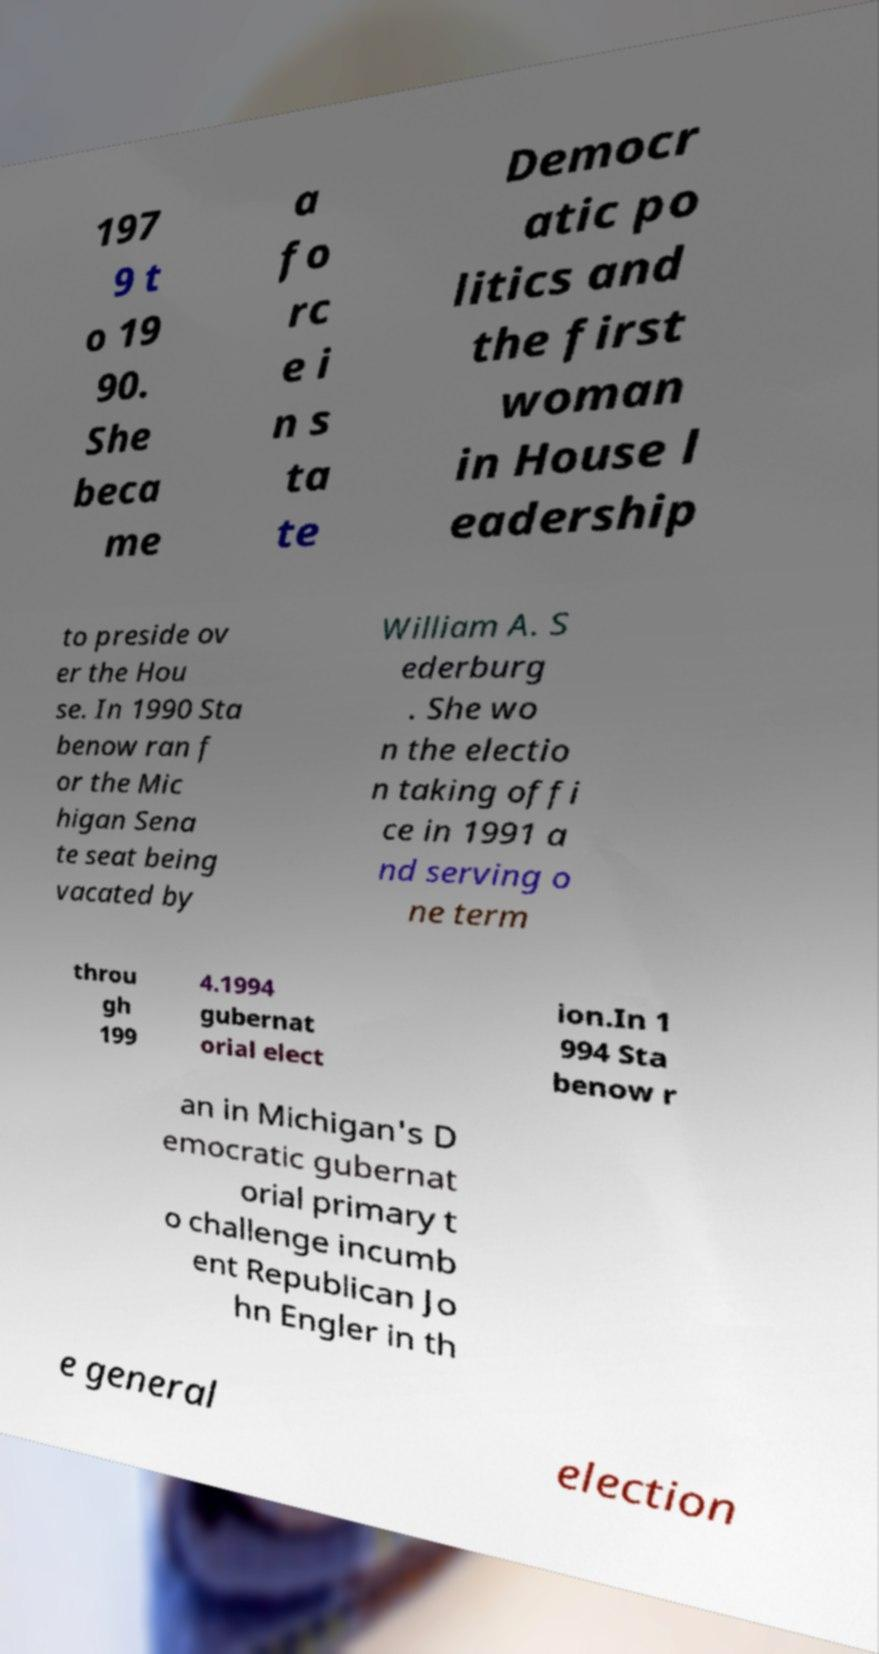I need the written content from this picture converted into text. Can you do that? 197 9 t o 19 90. She beca me a fo rc e i n s ta te Democr atic po litics and the first woman in House l eadership to preside ov er the Hou se. In 1990 Sta benow ran f or the Mic higan Sena te seat being vacated by William A. S ederburg . She wo n the electio n taking offi ce in 1991 a nd serving o ne term throu gh 199 4.1994 gubernat orial elect ion.In 1 994 Sta benow r an in Michigan's D emocratic gubernat orial primary t o challenge incumb ent Republican Jo hn Engler in th e general election 